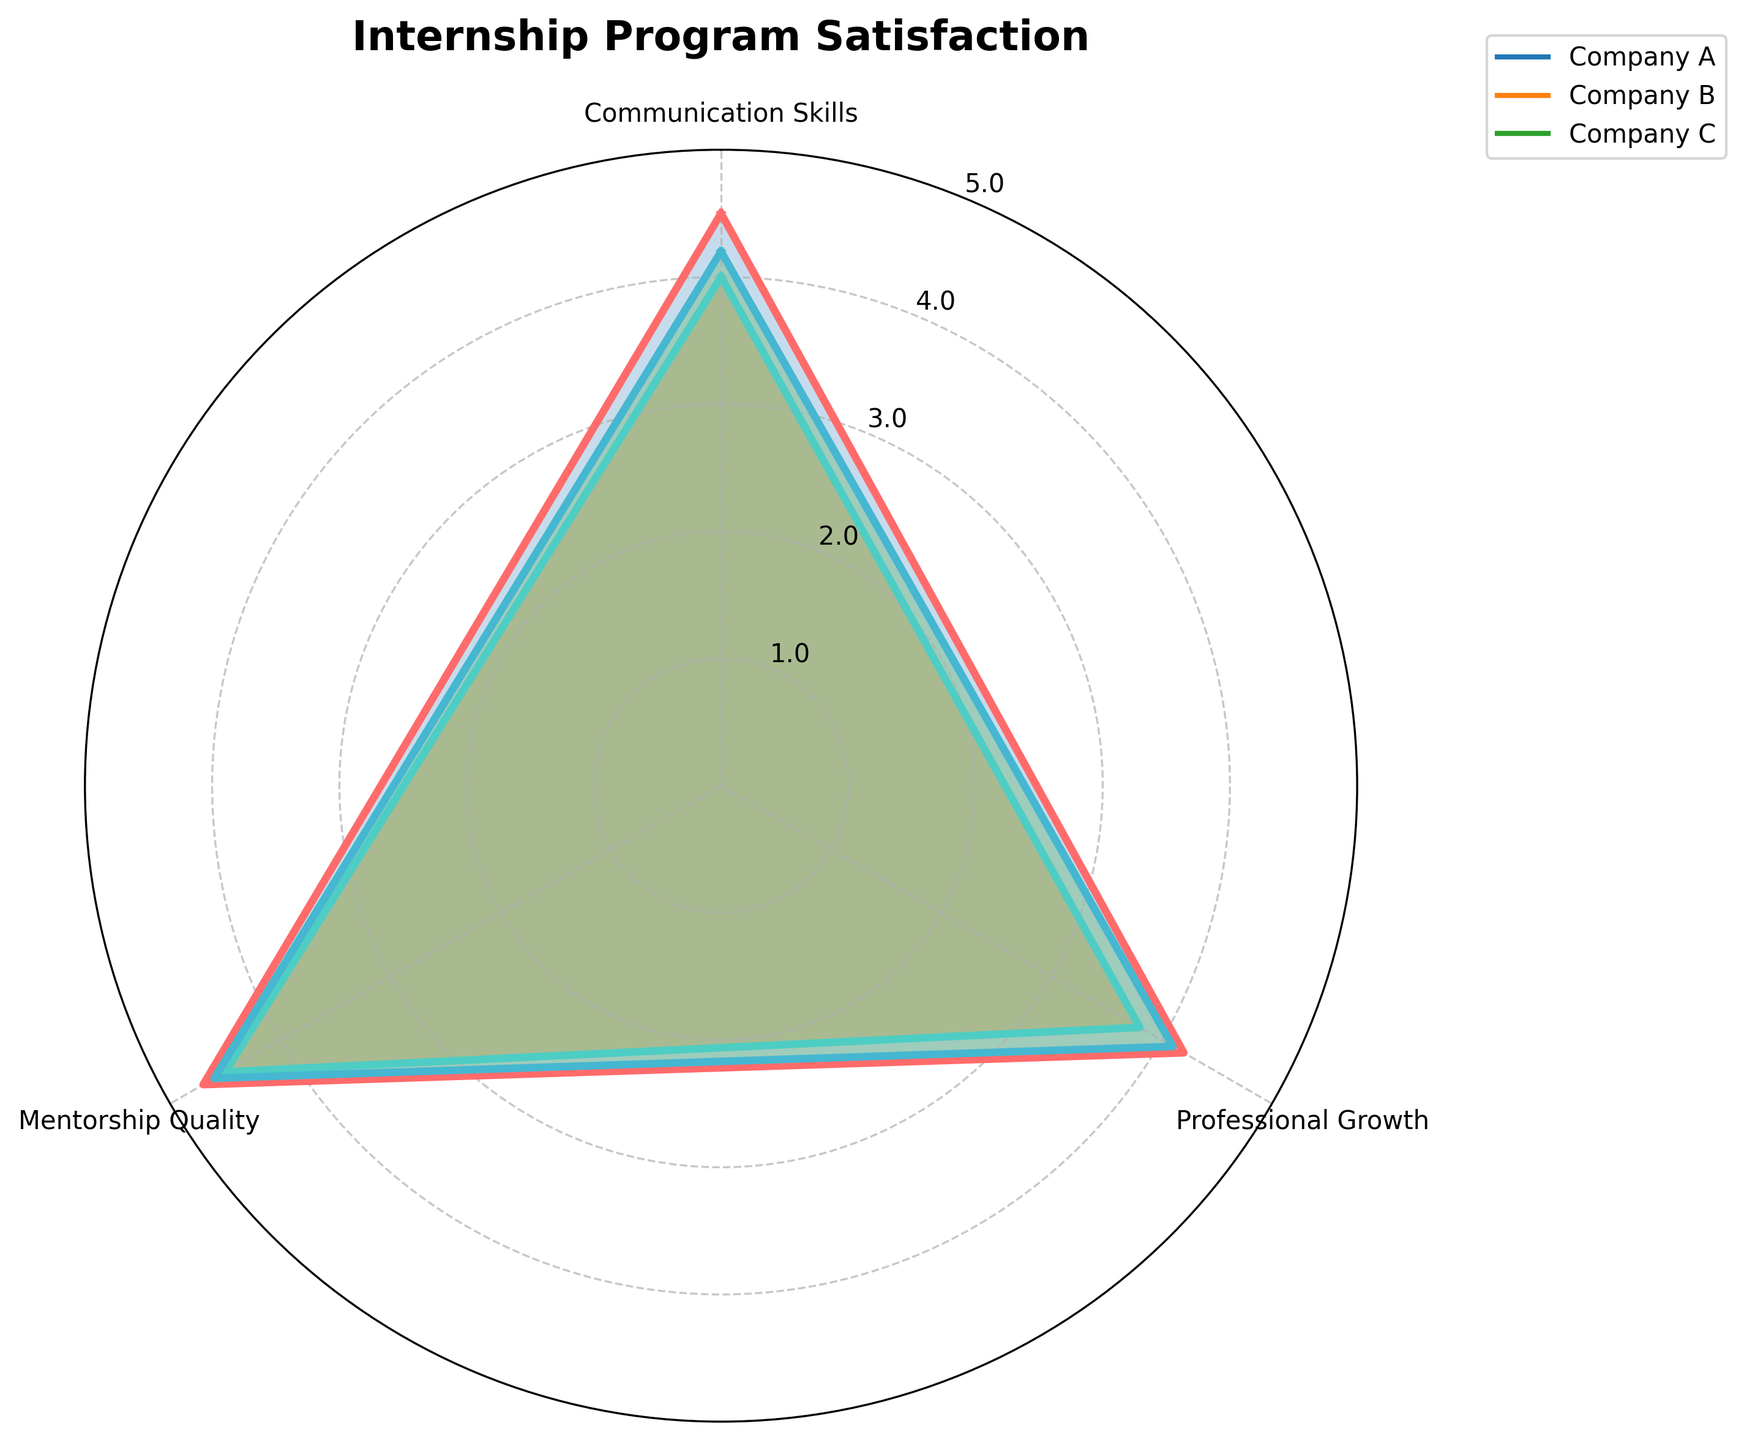Which group scored the highest in Communication Skills? Look at the values for Communication Skills for each group. Company A has 4.5, Company B has 4.0, and Company C has 4.2. Therefore, Company A scored the highest.
Answer: Company A What is the range of scores for Professional Growth among all groups? To find the range, subtract the smallest value from the largest value in the Professional Growth category. The values are 4.2, 3.8, and 4.1. The range is 4.2 - 3.8 = 0.4.
Answer: 0.4 Which group has the lowest overall satisfaction? The overall satisfaction can be estimated by averaging the scores for each category per group. Calculate the average for each group:
- Company A: (4.5 + 4.2 + 4.7) / 3 = 4.47
- Company B: (4.0 + 3.8 + 4.5) / 3 = 4.1
- Company C: (4.2 + 4.1 + 4.6) / 3 = 4.3
Company B has the lowest overall satisfaction score.
Answer: Company B Are there any categories where all groups have scores equal to or above 4.0? Compare the values in each category:
- Communication Skills: 4.5, 4.0, 4.2 (all >= 4.0)
- Professional Growth: 4.2, 3.8, 4.1 (one is below 4.0)
- Mentorship Quality: 4.7, 4.5, 4.6 (all >= 4.0)
Both Communication Skills and Mentorship Quality categories meet the criteria.
Answer: Communication Skills, Mentorship Quality Which group has the highest average Mentorship Quality score? Compare the Mentorship Quality scores: Company A has 4.7, Company B has 4.5, and Company C has 4.6. The highest score is 4.7, which belongs to Company A.
Answer: Company A What is the difference in average scores between Company A and Company B? Calculate the overall average for both groups:
- Company A: (4.5 + 4.2 + 4.7) / 3 = 4.47
- Company B: (4.0 + 3.8 + 4.5) / 3 = 4.1
The difference is 4.47 - 4.1 = 0.37.
Answer: 0.37 How does Company C's Communication Skills score compare to its Professional Growth score? Company C's Communication Skills score is 4.2 and Professional Growth score is 4.1. Since 4.2 > 4.1, the Communication Skills score is higher.
Answer: Higher Which categories have Company B scored lower compared to Company A? Compare Company B's scores against Company A:
- Communication Skills: 4.0 (B) < 4.5 (A)
- Professional Growth: 3.8 (B) < 4.2 (A)
- Mentorship Quality: 4.5 (B) < 4.7 (A)
Company B has scored lower in all categories compared to Company A.
Answer: All categories Is there any category where Company C scores are exactly in the middle of Company A and Company B? Check each category to see if Company C's score is between Company A and Company B:
- Communication Skills: A (4.5), B (4.0), C (4.2) – Not exactly in the middle
- Professional Growth: A (4.2), B (3.8), C (4.1) – Not exactly in the middle
- Mentorship Quality: A (4.7), B (4.5), C (4.6) – Company C is exactly in the middle here.
Therefore, Company C's Mentorship Quality score is exactly in the middle.
Answer: Mentorship Quality 